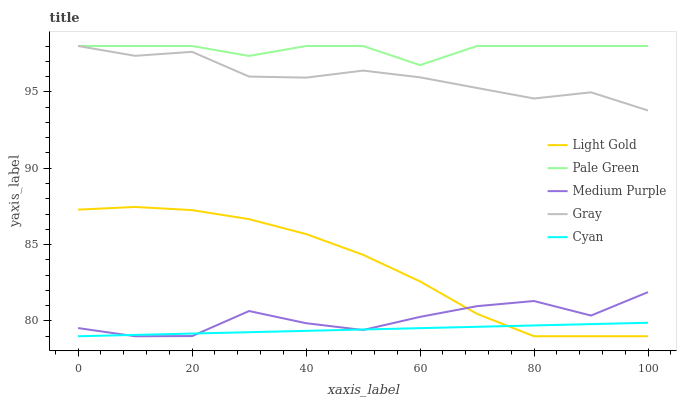Does Cyan have the minimum area under the curve?
Answer yes or no. Yes. Does Pale Green have the maximum area under the curve?
Answer yes or no. Yes. Does Gray have the minimum area under the curve?
Answer yes or no. No. Does Gray have the maximum area under the curve?
Answer yes or no. No. Is Cyan the smoothest?
Answer yes or no. Yes. Is Medium Purple the roughest?
Answer yes or no. Yes. Is Gray the smoothest?
Answer yes or no. No. Is Gray the roughest?
Answer yes or no. No. Does Medium Purple have the lowest value?
Answer yes or no. Yes. Does Gray have the lowest value?
Answer yes or no. No. Does Pale Green have the highest value?
Answer yes or no. Yes. Does Light Gold have the highest value?
Answer yes or no. No. Is Medium Purple less than Pale Green?
Answer yes or no. Yes. Is Pale Green greater than Medium Purple?
Answer yes or no. Yes. Does Gray intersect Pale Green?
Answer yes or no. Yes. Is Gray less than Pale Green?
Answer yes or no. No. Is Gray greater than Pale Green?
Answer yes or no. No. Does Medium Purple intersect Pale Green?
Answer yes or no. No. 